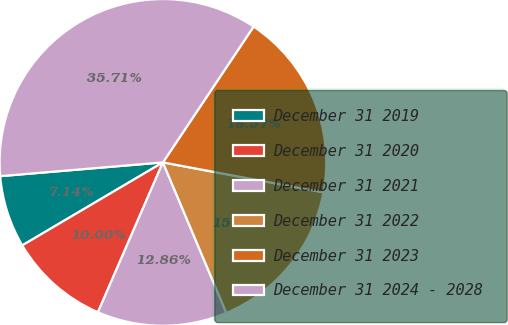<chart> <loc_0><loc_0><loc_500><loc_500><pie_chart><fcel>December 31 2019<fcel>December 31 2020<fcel>December 31 2021<fcel>December 31 2022<fcel>December 31 2023<fcel>December 31 2024 - 2028<nl><fcel>7.14%<fcel>10.0%<fcel>12.86%<fcel>15.71%<fcel>18.57%<fcel>35.71%<nl></chart> 